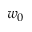<formula> <loc_0><loc_0><loc_500><loc_500>w _ { 0 }</formula> 